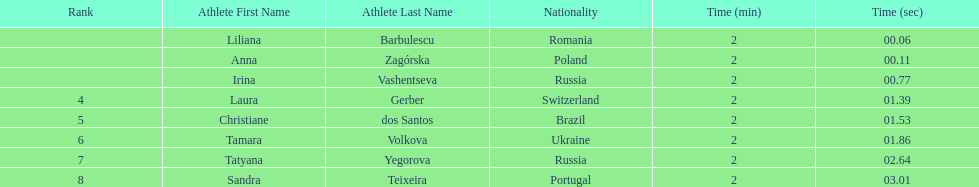How many runners finished with their time below 2:01? 3. 